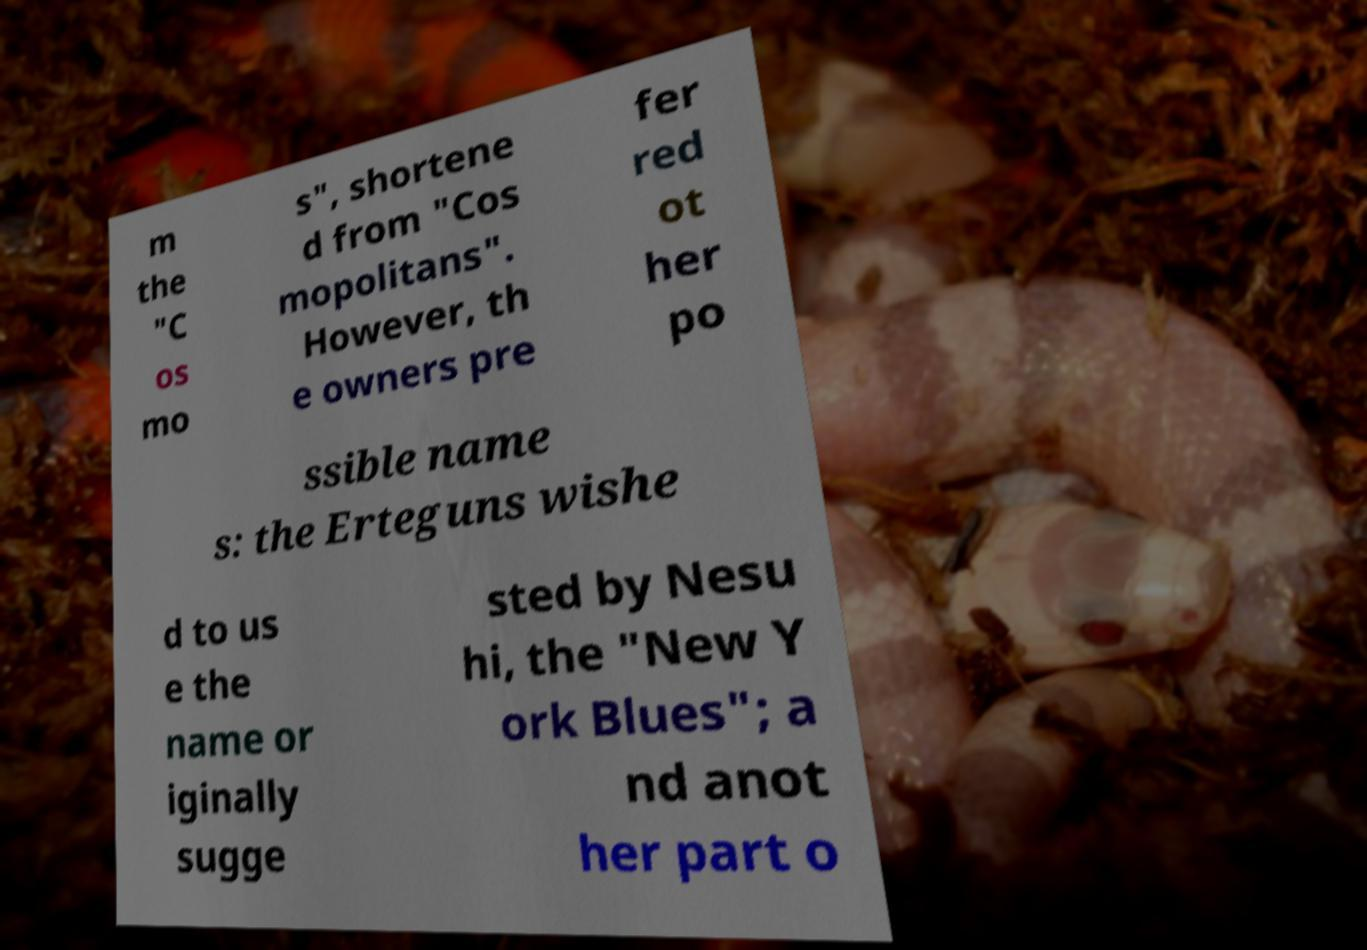Can you read and provide the text displayed in the image?This photo seems to have some interesting text. Can you extract and type it out for me? m the "C os mo s", shortene d from "Cos mopolitans". However, th e owners pre fer red ot her po ssible name s: the Erteguns wishe d to us e the name or iginally sugge sted by Nesu hi, the "New Y ork Blues"; a nd anot her part o 